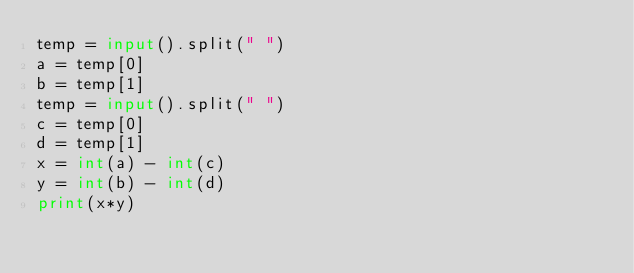<code> <loc_0><loc_0><loc_500><loc_500><_Python_>temp = input().split(" ")
a = temp[0]
b = temp[1]
temp = input().split(" ")
c = temp[0]
d = temp[1]
x = int(a) - int(c)
y = int(b) - int(d)
print(x*y)
</code> 